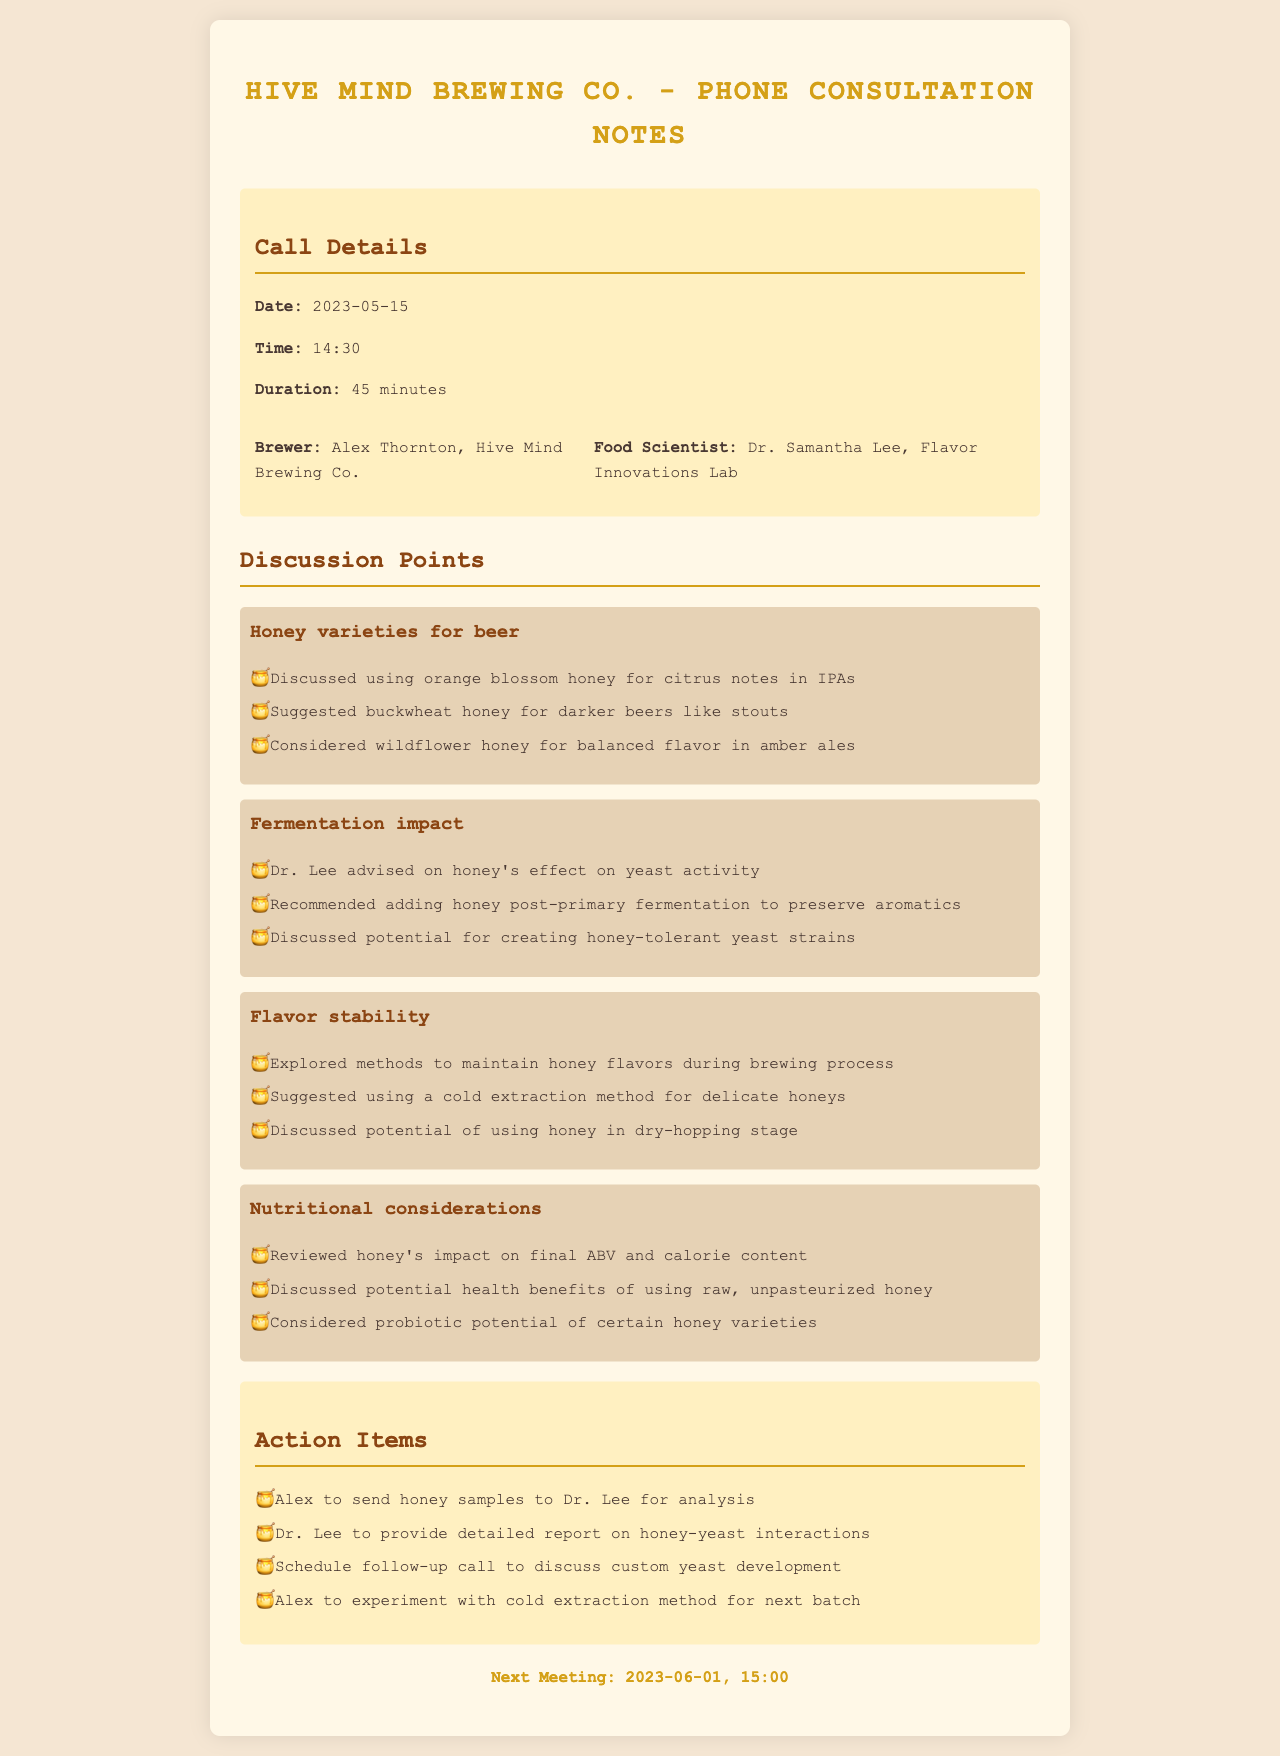what is the date of the phone consultation? The date of the phone consultation is provided in the call details section of the document.
Answer: 2023-05-15 who is the brewer in the consultation? The brewer's name is listed among the participants of the call.
Answer: Alex Thornton what type of honey was discussed for IPAs? The specific detail about honey types can be found in the discussion points related to honey varieties.
Answer: orange blossom honey what is the recommended method to preserve honey aromatics? This method is specifically mentioned by Dr. Lee in the consultation notes.
Answer: adding honey post-primary fermentation when is the next meeting scheduled? The next meeting date is mentioned at the end of the document.
Answer: 2023-06-01 what is one potential health benefit of using raw honey? The health benefits of honey are discussed in the nutritional considerations section.
Answer: probiotic potential what impact does honey have on final ABV? This information is discussed under nutritional considerations in the consultation notes.
Answer: impact on final ABV who is the food scientist involved in the consultation? The food scientist's name is provided in the call participants section.
Answer: Dr. Samantha Lee 